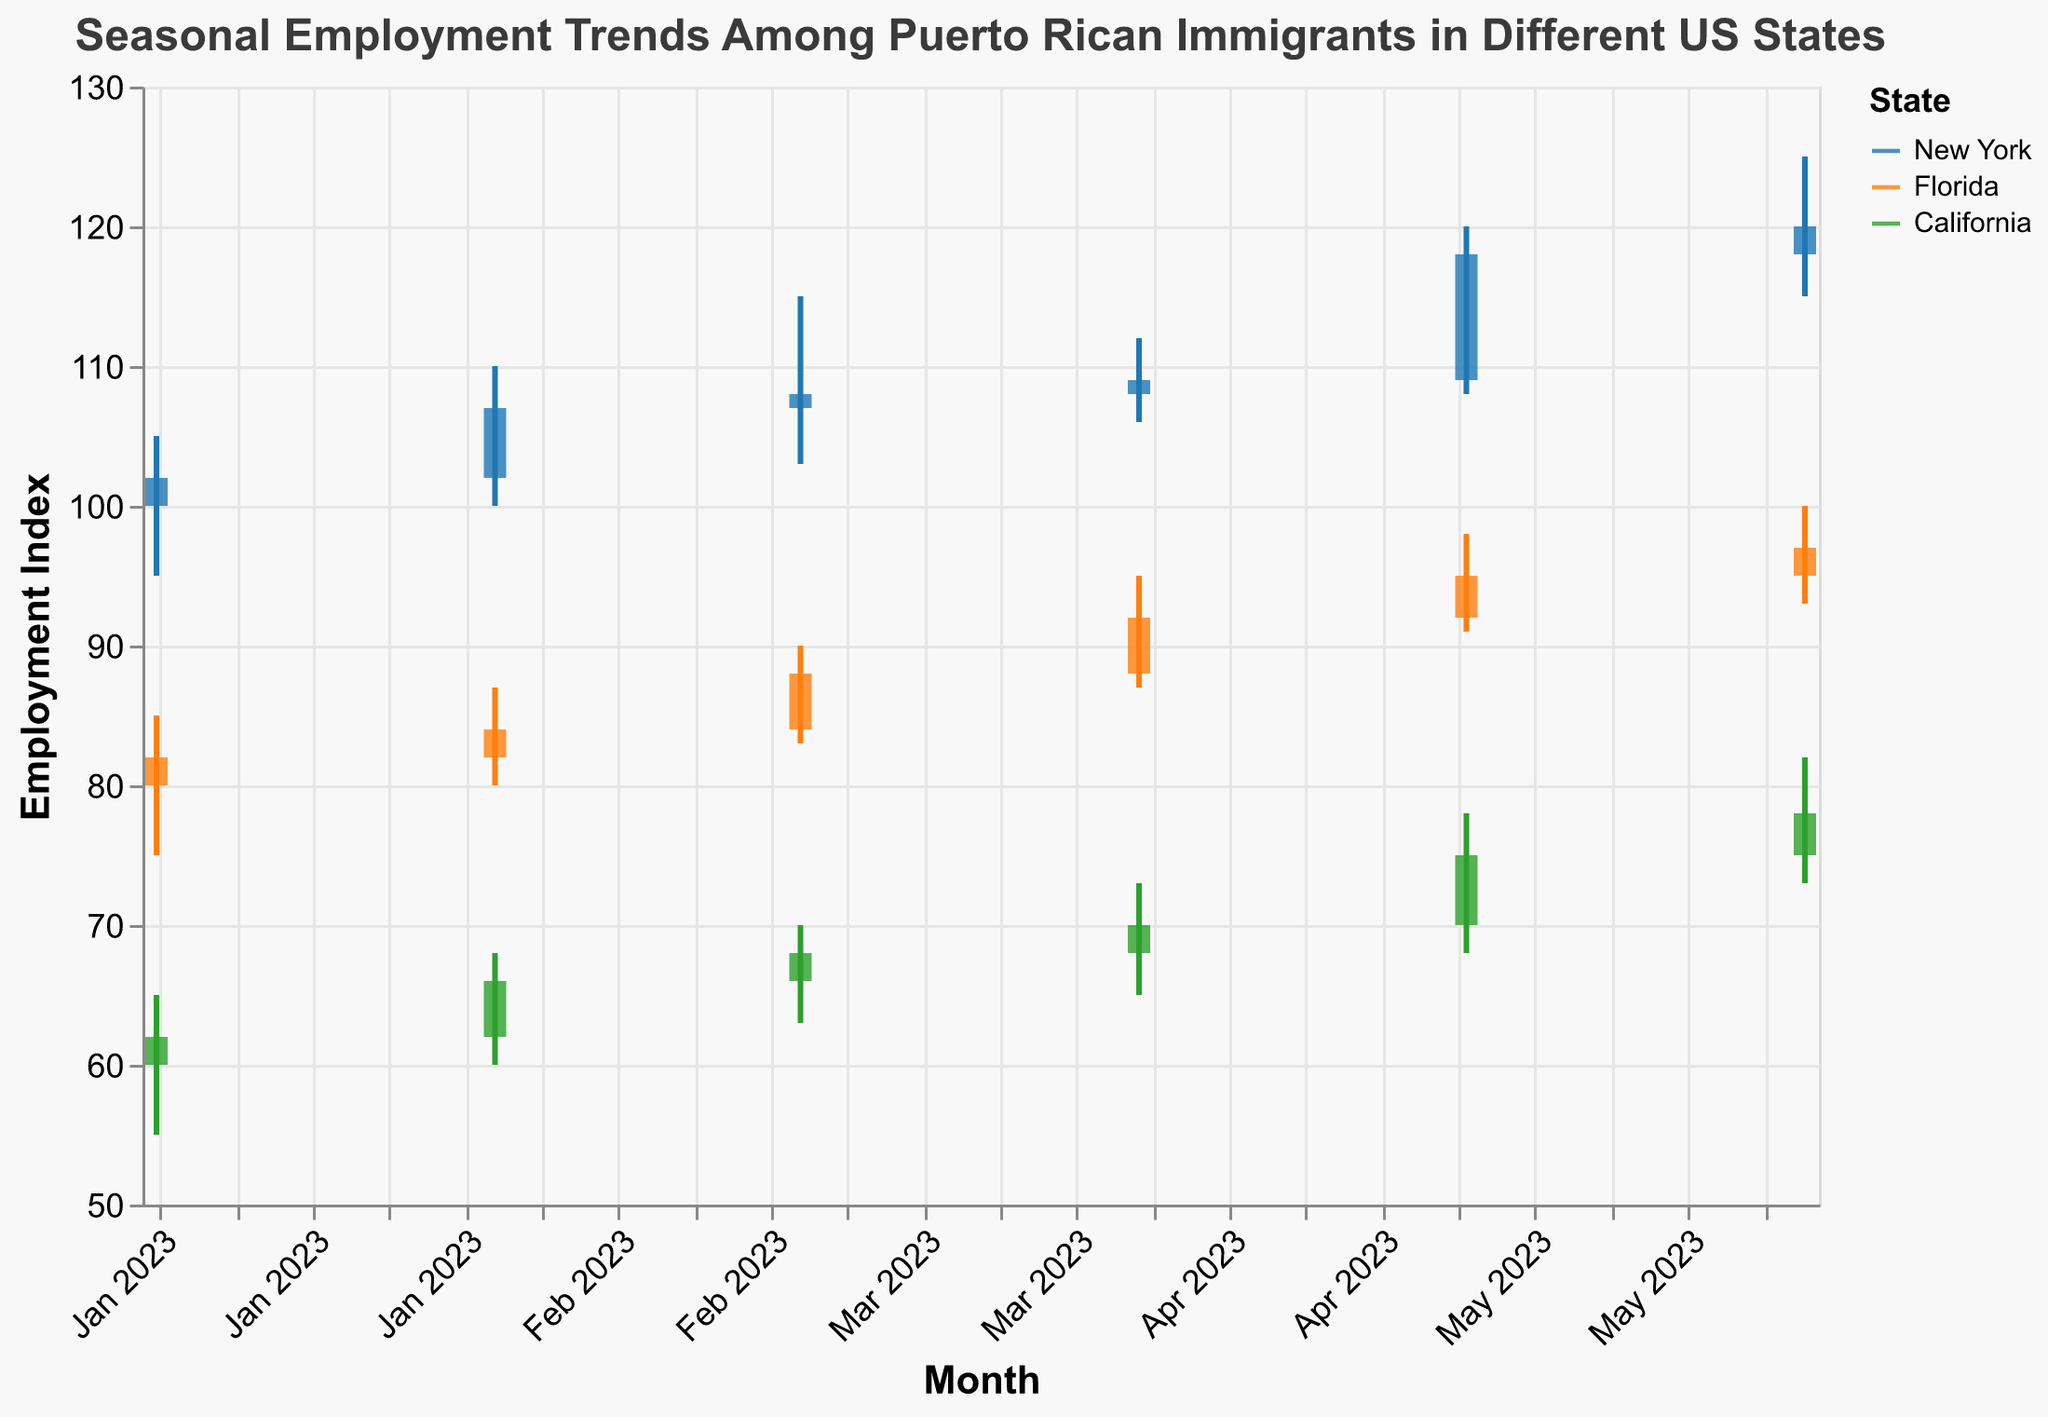What is the title of the figure? The title of the figure is displayed at the top of the chart. It helps to provide context about the data presented.
Answer: Seasonal Employment Trends Among Puerto Rican Immigrants in Different US States Which state shows the highest employment index in June 2023? To find the highest employment index, look for the highest "Close" value in the June 2023 entries.
Answer: New York In which month did California have the lowest employment index? Examine the "Low" values across all months for California and identify the lowest value.
Answer: January 2023 Compare the employment index trends from May to June 2023 for all states. Which state shows the highest increase? Calculate the difference between the "Close" values of May and June 2023 for each state and find the highest increase. New York's increase is 120-118 = 2, Florida's increase is 97-95 = 2, and California's increase is 78-75 = 3.
Answer: California Which state had the highest volatility in January 2023? Volatility can be measured by the range (High - Low). Calculate the range for January 2023 for each state and identify which is the highest. New York's range is 105-95 = 10, Florida's range is 85-75 = 10, California's range is 65-55 = 10. All states have the same range.
Answer: All states had the same volatility What is the trend of the employment index in New York from January to June 2023? Observe the "Close" values for New York from January to June 2023 to determine if the trend is increasing, decreasing, or stable.
Answer: Increasing Which state shows the least difference between the "Open" and "Close" values for June 2023? To find the state with the least difference, subtract the "Close" value from the "Open" value for each state in June 2023 and compare them. New York's difference is 120-118 = 2, Florida's difference is 97-95 = 2, California's difference is 78-75 = 3.
Answer: New York and Florida Across all states, which month has the highest combined employment index "Close" value? Add the "Close" values for all states for each month and identify the month with the highest total. January: 246, February: 257, March: 264, April: 271, May: 288, June: 295.
Answer: June Which state shows a steady increase in employment index from January to June 2023 without any fluctuation downward? For a steady increase, every month's "Close" value should be higher than the previous month's "Close" value. Florida's "Close" values increase steadily without any downward fluctuation.
Answer: Florida 